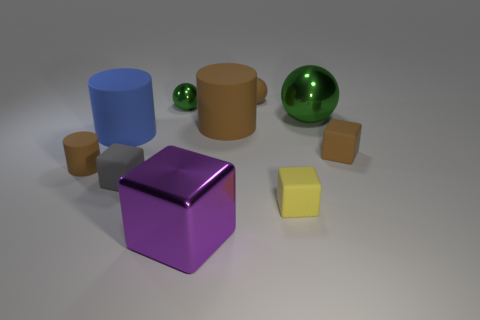Subtract all green balls. How many were subtracted if there are1green balls left? 1 Subtract all brown rubber blocks. How many blocks are left? 3 Subtract all gray blocks. How many blocks are left? 3 Subtract all brown blocks. How many green balls are left? 2 Subtract all balls. How many objects are left? 7 Add 4 big red rubber blocks. How many big red rubber blocks exist? 4 Subtract 1 yellow blocks. How many objects are left? 9 Subtract 4 cubes. How many cubes are left? 0 Subtract all blue cylinders. Subtract all yellow cubes. How many cylinders are left? 2 Subtract all blue rubber things. Subtract all tiny metallic spheres. How many objects are left? 8 